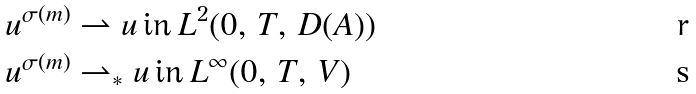Convert formula to latex. <formula><loc_0><loc_0><loc_500><loc_500>u ^ { \sigma ( m ) } & \rightharpoonup u \, \text {in} \, L ^ { 2 } ( 0 , \, T , \, D ( A ) ) \\ u ^ { \sigma ( m ) } & \rightharpoonup _ { \ast } u \, \text {in} \, L ^ { \infty } ( 0 , \, T , \, V )</formula> 